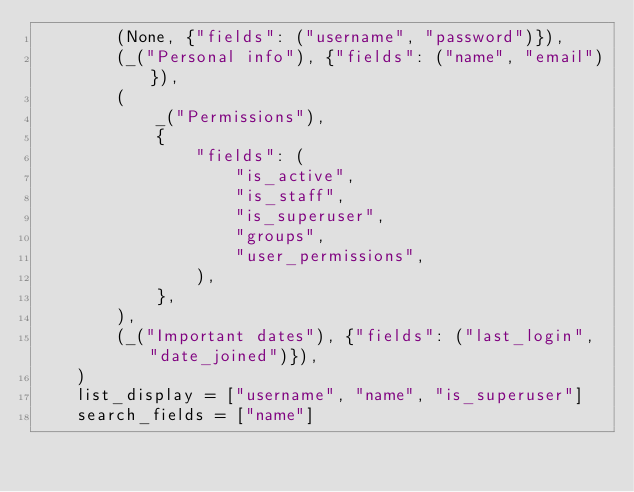<code> <loc_0><loc_0><loc_500><loc_500><_Python_>        (None, {"fields": ("username", "password")}),
        (_("Personal info"), {"fields": ("name", "email")}),
        (
            _("Permissions"),
            {
                "fields": (
                    "is_active",
                    "is_staff",
                    "is_superuser",
                    "groups",
                    "user_permissions",
                ),
            },
        ),
        (_("Important dates"), {"fields": ("last_login", "date_joined")}),
    )
    list_display = ["username", "name", "is_superuser"]
    search_fields = ["name"]
</code> 